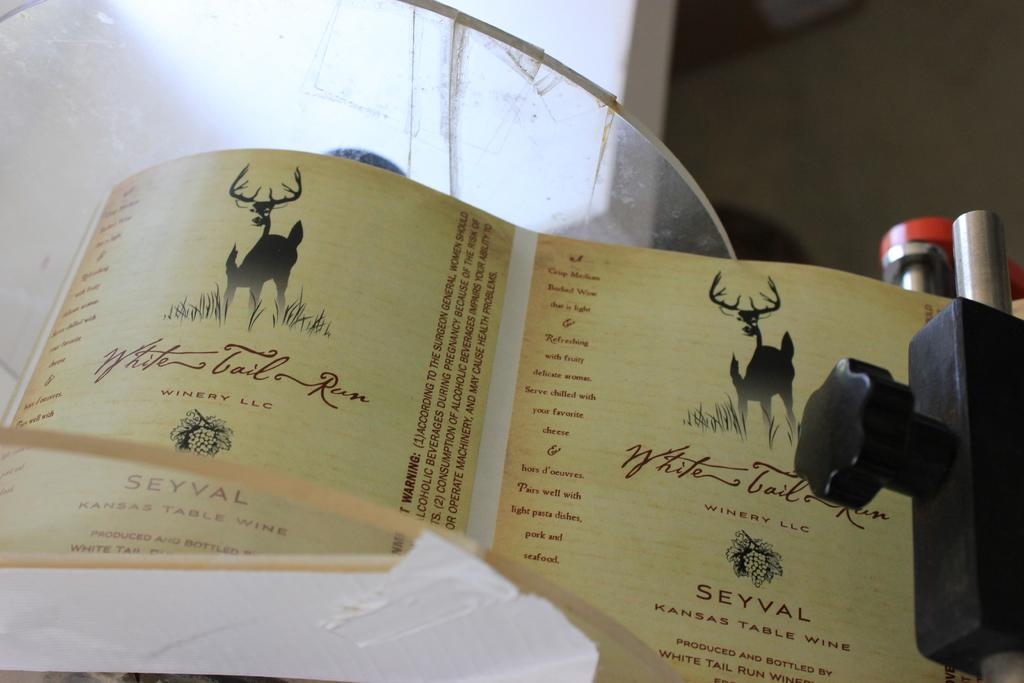<image>
Present a compact description of the photo's key features. A piece of paper giving information about White Tail Run Winery LLC 